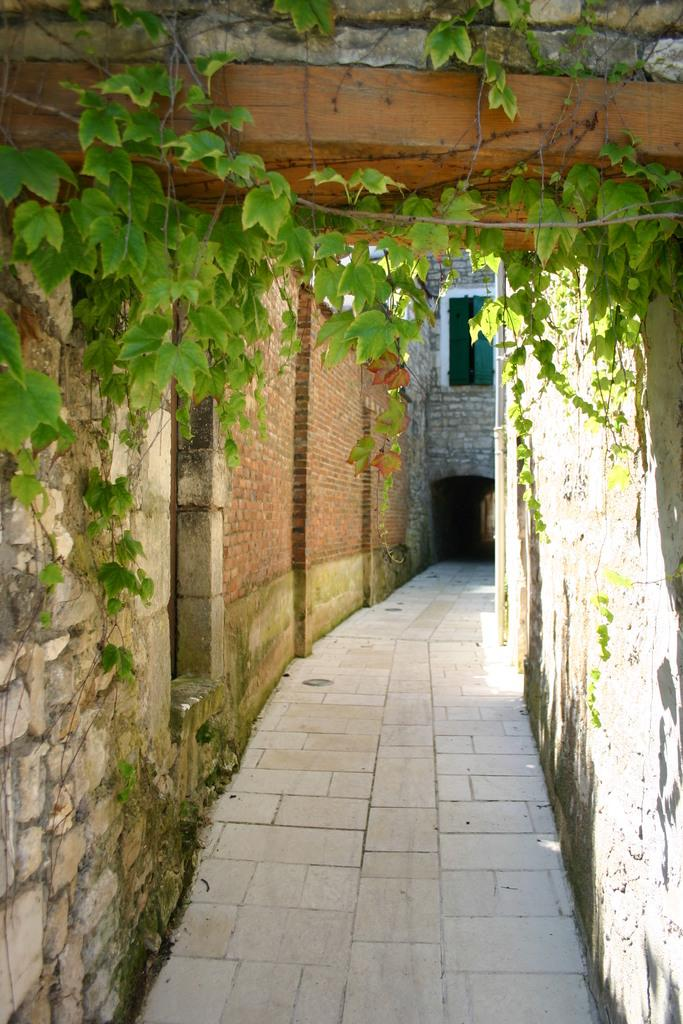What type of structures can be seen in the image? There are walls in the image. What feature allows light and air to enter the space? There is a window in the image. What type of surface can be used for walking or moving? There is a pathway in the image. What type of natural elements can be seen in the image? Leaves are present in the image. What type of dust can be seen on the father's shoulder in the image? There is no father or dust present in the image. 